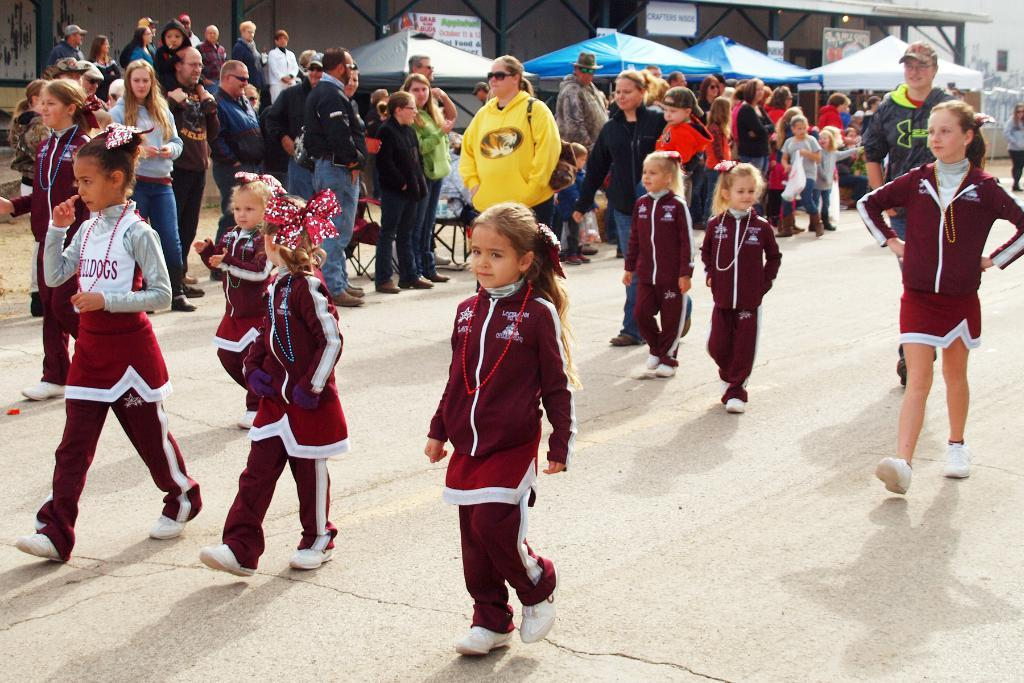What can be seen in the background of the image? There are tents in the background of the image. What is happening in the foreground of the image? There are people standing in the image. What activity are the children engaged in? Children are walking on the road in the image. What type of flesh can be seen hanging from the tents in the image? There is no flesh present in the image; it features tents in the background. What show is being performed by the people standing in the image? There is no show being performed in the image; the people are simply standing. 